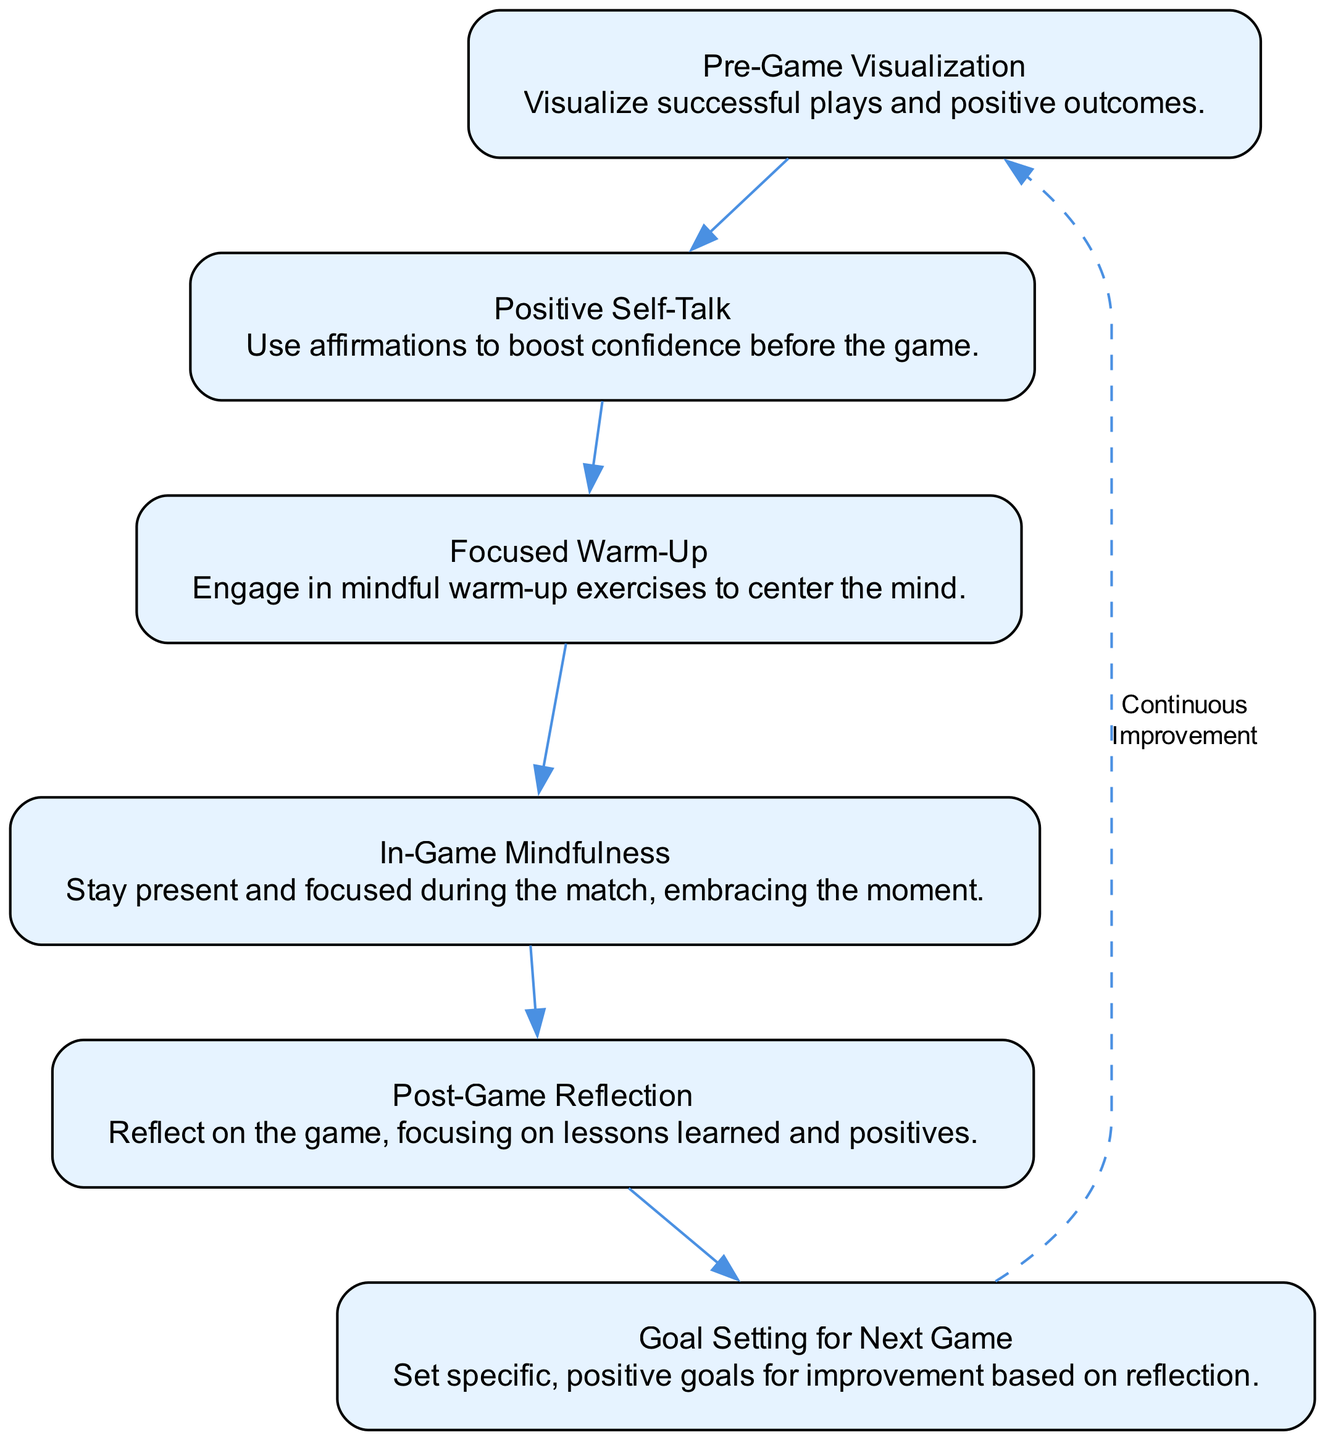What is the first node in the flowchart? The first node indicates "Pre-Game Visualization," which is the starting point of the mindset progression for a soccer player. This can be directly checked from the top node in the diagram.
Answer: Pre-Game Visualization How many nodes are there in the flowchart? By counting each unique element in the flowchart, we see there are six distinct nodes that represent different stages in the player's mindset from pre-game to post-game.
Answer: 6 What is the last step before post-game reflection? Before reaching "Post-Game Reflection," the last step shown in the diagram is "In-Game Mindfulness," which helps maintain focus during the match. This can be determined by tracing the arrows leading toward the last node.
Answer: In-Game Mindfulness What is the description of the "Focused Warm-Up" node? The description for the "Focused Warm-Up" node emphasizes engaging in mindful warm-up exercises to center the mind. This can be found in the specific text associated with that node in the flowchart.
Answer: Engage in mindful warm-up exercises to center the mind What does the dashed line connecting the last node to the first node indicate? The dashed line signifies "Continuous Improvement," implying a cyclical process where the mindset continually evolves and repeats after each game. This connection illustrates how the practices are intended to be repeated and built upon over time.
Answer: Continuous Improvement What two nodes are directly connected to "Post-Game Reflection"? The "Post-Game Reflection" node connects to "In-Game Mindfulness," coming before it, and leads to "Goal Setting for Next Game." The question can be answered by checking the nodes connected to "Post-Game Reflection" in the diagram.
Answer: In-Game Mindfulness and Goal Setting for Next Game What is the primary focus of the flowchart? The primary focus is to outline the progression of a soccer player’s mindset, emphasizing positivity and learning throughout various stages of the game experience. This can be gleaned from the overall theme and descriptions provided within the nodes.
Answer: Positivity and learning What is the relationship between 'Goal Setting for Next Game' and 'Post-Game Reflection'? "Goal Setting for Next Game" follows the "Post-Game Reflection" in the flow, indicating that setting future goals is based on lessons learned from the game. This relationship showcases a logical progression inherent in the diagram's structure.
Answer: Future goals based on reflection 